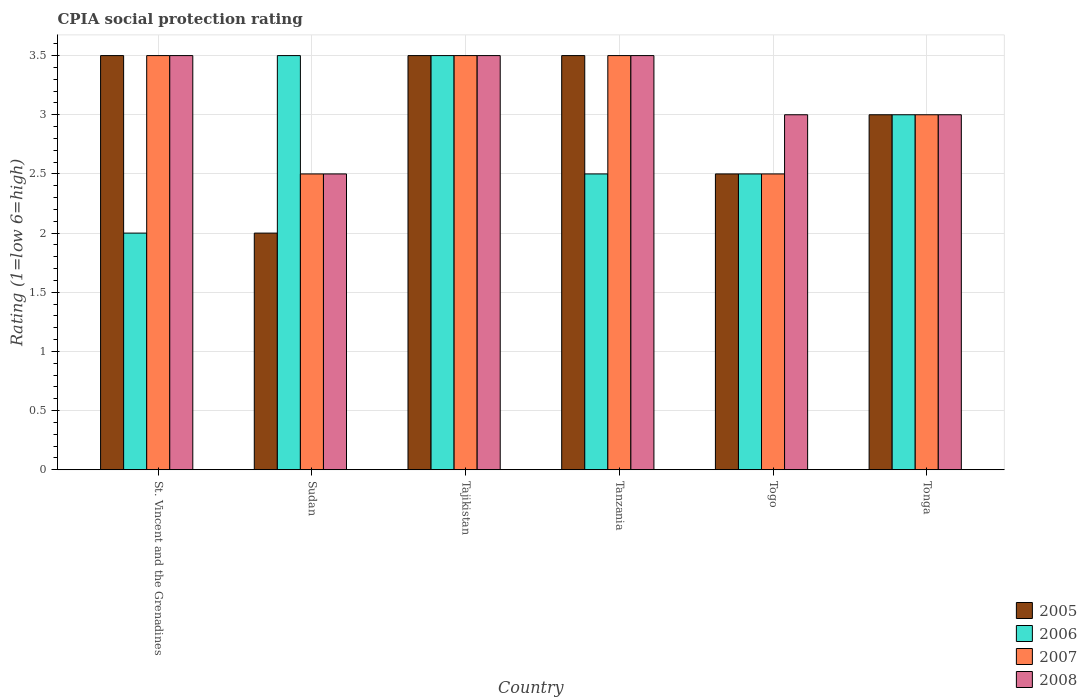How many different coloured bars are there?
Give a very brief answer. 4. Are the number of bars per tick equal to the number of legend labels?
Ensure brevity in your answer.  Yes. Are the number of bars on each tick of the X-axis equal?
Ensure brevity in your answer.  Yes. What is the label of the 2nd group of bars from the left?
Provide a short and direct response. Sudan. What is the CPIA rating in 2007 in Togo?
Give a very brief answer. 2.5. Across all countries, what is the minimum CPIA rating in 2008?
Your response must be concise. 2.5. In which country was the CPIA rating in 2008 maximum?
Your answer should be compact. St. Vincent and the Grenadines. In which country was the CPIA rating in 2006 minimum?
Your answer should be compact. St. Vincent and the Grenadines. What is the difference between the CPIA rating in 2005 in St. Vincent and the Grenadines and that in Tanzania?
Your response must be concise. 0. What is the difference between the CPIA rating in 2006 in Togo and the CPIA rating in 2008 in Tajikistan?
Your answer should be very brief. -1. Is the difference between the CPIA rating in 2006 in Sudan and Togo greater than the difference between the CPIA rating in 2008 in Sudan and Togo?
Provide a short and direct response. Yes. What is the difference between the highest and the second highest CPIA rating in 2006?
Ensure brevity in your answer.  -0.5. What is the difference between the highest and the lowest CPIA rating in 2005?
Keep it short and to the point. 1.5. What does the 2nd bar from the left in Tajikistan represents?
Your response must be concise. 2006. Is it the case that in every country, the sum of the CPIA rating in 2006 and CPIA rating in 2007 is greater than the CPIA rating in 2008?
Make the answer very short. Yes. How many bars are there?
Give a very brief answer. 24. Are all the bars in the graph horizontal?
Ensure brevity in your answer.  No. How many countries are there in the graph?
Ensure brevity in your answer.  6. Are the values on the major ticks of Y-axis written in scientific E-notation?
Give a very brief answer. No. Does the graph contain any zero values?
Offer a very short reply. No. Does the graph contain grids?
Your response must be concise. Yes. How are the legend labels stacked?
Your answer should be very brief. Vertical. What is the title of the graph?
Your answer should be very brief. CPIA social protection rating. What is the Rating (1=low 6=high) of 2005 in Sudan?
Provide a short and direct response. 2. What is the Rating (1=low 6=high) of 2006 in Sudan?
Ensure brevity in your answer.  3.5. What is the Rating (1=low 6=high) of 2007 in Sudan?
Provide a succinct answer. 2.5. What is the Rating (1=low 6=high) of 2008 in Sudan?
Offer a terse response. 2.5. What is the Rating (1=low 6=high) in 2005 in Tajikistan?
Provide a short and direct response. 3.5. What is the Rating (1=low 6=high) in 2008 in Tajikistan?
Give a very brief answer. 3.5. What is the Rating (1=low 6=high) in 2006 in Tanzania?
Keep it short and to the point. 2.5. What is the Rating (1=low 6=high) of 2008 in Tanzania?
Offer a very short reply. 3.5. What is the Rating (1=low 6=high) in 2005 in Togo?
Ensure brevity in your answer.  2.5. What is the Rating (1=low 6=high) of 2006 in Togo?
Provide a succinct answer. 2.5. What is the Rating (1=low 6=high) in 2008 in Togo?
Provide a succinct answer. 3. What is the Rating (1=low 6=high) in 2006 in Tonga?
Your answer should be very brief. 3. What is the Rating (1=low 6=high) of 2008 in Tonga?
Keep it short and to the point. 3. Across all countries, what is the maximum Rating (1=low 6=high) in 2005?
Give a very brief answer. 3.5. Across all countries, what is the maximum Rating (1=low 6=high) in 2007?
Ensure brevity in your answer.  3.5. Across all countries, what is the maximum Rating (1=low 6=high) in 2008?
Your answer should be compact. 3.5. Across all countries, what is the minimum Rating (1=low 6=high) in 2005?
Make the answer very short. 2. Across all countries, what is the minimum Rating (1=low 6=high) in 2006?
Make the answer very short. 2. What is the difference between the Rating (1=low 6=high) of 2006 in St. Vincent and the Grenadines and that in Tajikistan?
Ensure brevity in your answer.  -1.5. What is the difference between the Rating (1=low 6=high) of 2007 in St. Vincent and the Grenadines and that in Tajikistan?
Offer a terse response. 0. What is the difference between the Rating (1=low 6=high) in 2008 in St. Vincent and the Grenadines and that in Tajikistan?
Your answer should be compact. 0. What is the difference between the Rating (1=low 6=high) in 2006 in St. Vincent and the Grenadines and that in Tanzania?
Offer a very short reply. -0.5. What is the difference between the Rating (1=low 6=high) in 2008 in St. Vincent and the Grenadines and that in Tanzania?
Your answer should be very brief. 0. What is the difference between the Rating (1=low 6=high) of 2005 in St. Vincent and the Grenadines and that in Togo?
Offer a very short reply. 1. What is the difference between the Rating (1=low 6=high) in 2006 in St. Vincent and the Grenadines and that in Togo?
Provide a succinct answer. -0.5. What is the difference between the Rating (1=low 6=high) in 2005 in St. Vincent and the Grenadines and that in Tonga?
Keep it short and to the point. 0.5. What is the difference between the Rating (1=low 6=high) of 2007 in St. Vincent and the Grenadines and that in Tonga?
Provide a short and direct response. 0.5. What is the difference between the Rating (1=low 6=high) of 2008 in St. Vincent and the Grenadines and that in Tonga?
Provide a short and direct response. 0.5. What is the difference between the Rating (1=low 6=high) in 2005 in Sudan and that in Tajikistan?
Keep it short and to the point. -1.5. What is the difference between the Rating (1=low 6=high) in 2006 in Sudan and that in Tajikistan?
Make the answer very short. 0. What is the difference between the Rating (1=low 6=high) in 2008 in Sudan and that in Tajikistan?
Your response must be concise. -1. What is the difference between the Rating (1=low 6=high) in 2005 in Sudan and that in Tanzania?
Give a very brief answer. -1.5. What is the difference between the Rating (1=low 6=high) in 2006 in Sudan and that in Tanzania?
Provide a succinct answer. 1. What is the difference between the Rating (1=low 6=high) in 2007 in Sudan and that in Tanzania?
Make the answer very short. -1. What is the difference between the Rating (1=low 6=high) in 2008 in Sudan and that in Tanzania?
Offer a terse response. -1. What is the difference between the Rating (1=low 6=high) in 2007 in Sudan and that in Togo?
Ensure brevity in your answer.  0. What is the difference between the Rating (1=low 6=high) of 2008 in Sudan and that in Togo?
Provide a short and direct response. -0.5. What is the difference between the Rating (1=low 6=high) of 2007 in Sudan and that in Tonga?
Your answer should be very brief. -0.5. What is the difference between the Rating (1=low 6=high) in 2005 in Tajikistan and that in Togo?
Your answer should be very brief. 1. What is the difference between the Rating (1=low 6=high) of 2007 in Tajikistan and that in Togo?
Your answer should be very brief. 1. What is the difference between the Rating (1=low 6=high) of 2008 in Tajikistan and that in Togo?
Provide a short and direct response. 0.5. What is the difference between the Rating (1=low 6=high) of 2006 in Tajikistan and that in Tonga?
Offer a very short reply. 0.5. What is the difference between the Rating (1=low 6=high) of 2008 in Tajikistan and that in Tonga?
Offer a terse response. 0.5. What is the difference between the Rating (1=low 6=high) of 2007 in Tanzania and that in Togo?
Keep it short and to the point. 1. What is the difference between the Rating (1=low 6=high) of 2005 in Tanzania and that in Tonga?
Ensure brevity in your answer.  0.5. What is the difference between the Rating (1=low 6=high) in 2006 in Tanzania and that in Tonga?
Ensure brevity in your answer.  -0.5. What is the difference between the Rating (1=low 6=high) in 2008 in Tanzania and that in Tonga?
Offer a terse response. 0.5. What is the difference between the Rating (1=low 6=high) in 2005 in Togo and that in Tonga?
Your answer should be very brief. -0.5. What is the difference between the Rating (1=low 6=high) of 2008 in Togo and that in Tonga?
Your answer should be very brief. 0. What is the difference between the Rating (1=low 6=high) of 2005 in St. Vincent and the Grenadines and the Rating (1=low 6=high) of 2006 in Sudan?
Make the answer very short. 0. What is the difference between the Rating (1=low 6=high) of 2006 in St. Vincent and the Grenadines and the Rating (1=low 6=high) of 2007 in Sudan?
Your answer should be very brief. -0.5. What is the difference between the Rating (1=low 6=high) of 2006 in St. Vincent and the Grenadines and the Rating (1=low 6=high) of 2008 in Sudan?
Offer a very short reply. -0.5. What is the difference between the Rating (1=low 6=high) in 2005 in St. Vincent and the Grenadines and the Rating (1=low 6=high) in 2007 in Tajikistan?
Give a very brief answer. 0. What is the difference between the Rating (1=low 6=high) in 2005 in St. Vincent and the Grenadines and the Rating (1=low 6=high) in 2008 in Tajikistan?
Offer a very short reply. 0. What is the difference between the Rating (1=low 6=high) in 2006 in St. Vincent and the Grenadines and the Rating (1=low 6=high) in 2007 in Tajikistan?
Provide a short and direct response. -1.5. What is the difference between the Rating (1=low 6=high) of 2007 in St. Vincent and the Grenadines and the Rating (1=low 6=high) of 2008 in Tajikistan?
Your response must be concise. 0. What is the difference between the Rating (1=low 6=high) of 2005 in St. Vincent and the Grenadines and the Rating (1=low 6=high) of 2006 in Tanzania?
Provide a short and direct response. 1. What is the difference between the Rating (1=low 6=high) in 2005 in St. Vincent and the Grenadines and the Rating (1=low 6=high) in 2008 in Tanzania?
Offer a terse response. 0. What is the difference between the Rating (1=low 6=high) of 2006 in St. Vincent and the Grenadines and the Rating (1=low 6=high) of 2007 in Tanzania?
Your response must be concise. -1.5. What is the difference between the Rating (1=low 6=high) in 2005 in St. Vincent and the Grenadines and the Rating (1=low 6=high) in 2008 in Togo?
Provide a short and direct response. 0.5. What is the difference between the Rating (1=low 6=high) in 2005 in St. Vincent and the Grenadines and the Rating (1=low 6=high) in 2006 in Tonga?
Your answer should be compact. 0.5. What is the difference between the Rating (1=low 6=high) in 2006 in St. Vincent and the Grenadines and the Rating (1=low 6=high) in 2007 in Tonga?
Ensure brevity in your answer.  -1. What is the difference between the Rating (1=low 6=high) in 2006 in St. Vincent and the Grenadines and the Rating (1=low 6=high) in 2008 in Tonga?
Your answer should be very brief. -1. What is the difference between the Rating (1=low 6=high) in 2005 in Sudan and the Rating (1=low 6=high) in 2006 in Tajikistan?
Ensure brevity in your answer.  -1.5. What is the difference between the Rating (1=low 6=high) in 2005 in Sudan and the Rating (1=low 6=high) in 2008 in Tajikistan?
Offer a terse response. -1.5. What is the difference between the Rating (1=low 6=high) of 2006 in Sudan and the Rating (1=low 6=high) of 2007 in Tajikistan?
Your answer should be very brief. 0. What is the difference between the Rating (1=low 6=high) in 2006 in Sudan and the Rating (1=low 6=high) in 2008 in Tajikistan?
Offer a very short reply. 0. What is the difference between the Rating (1=low 6=high) in 2007 in Sudan and the Rating (1=low 6=high) in 2008 in Tajikistan?
Provide a succinct answer. -1. What is the difference between the Rating (1=low 6=high) in 2005 in Sudan and the Rating (1=low 6=high) in 2006 in Tanzania?
Make the answer very short. -0.5. What is the difference between the Rating (1=low 6=high) of 2005 in Sudan and the Rating (1=low 6=high) of 2007 in Tanzania?
Offer a very short reply. -1.5. What is the difference between the Rating (1=low 6=high) in 2005 in Sudan and the Rating (1=low 6=high) in 2008 in Tanzania?
Make the answer very short. -1.5. What is the difference between the Rating (1=low 6=high) in 2005 in Sudan and the Rating (1=low 6=high) in 2007 in Togo?
Your response must be concise. -0.5. What is the difference between the Rating (1=low 6=high) of 2005 in Sudan and the Rating (1=low 6=high) of 2006 in Tonga?
Make the answer very short. -1. What is the difference between the Rating (1=low 6=high) of 2006 in Sudan and the Rating (1=low 6=high) of 2008 in Tonga?
Your answer should be very brief. 0.5. What is the difference between the Rating (1=low 6=high) in 2005 in Tajikistan and the Rating (1=low 6=high) in 2006 in Tanzania?
Ensure brevity in your answer.  1. What is the difference between the Rating (1=low 6=high) in 2006 in Tajikistan and the Rating (1=low 6=high) in 2007 in Tanzania?
Your answer should be very brief. 0. What is the difference between the Rating (1=low 6=high) of 2006 in Tajikistan and the Rating (1=low 6=high) of 2008 in Tanzania?
Your answer should be very brief. 0. What is the difference between the Rating (1=low 6=high) in 2007 in Tajikistan and the Rating (1=low 6=high) in 2008 in Tanzania?
Keep it short and to the point. 0. What is the difference between the Rating (1=low 6=high) of 2006 in Tajikistan and the Rating (1=low 6=high) of 2007 in Togo?
Offer a terse response. 1. What is the difference between the Rating (1=low 6=high) of 2007 in Tajikistan and the Rating (1=low 6=high) of 2008 in Togo?
Your response must be concise. 0.5. What is the difference between the Rating (1=low 6=high) in 2005 in Tajikistan and the Rating (1=low 6=high) in 2006 in Tonga?
Give a very brief answer. 0.5. What is the difference between the Rating (1=low 6=high) of 2006 in Tajikistan and the Rating (1=low 6=high) of 2007 in Tonga?
Offer a terse response. 0.5. What is the difference between the Rating (1=low 6=high) in 2006 in Tajikistan and the Rating (1=low 6=high) in 2008 in Tonga?
Your answer should be very brief. 0.5. What is the difference between the Rating (1=low 6=high) in 2005 in Tanzania and the Rating (1=low 6=high) in 2007 in Togo?
Give a very brief answer. 1. What is the difference between the Rating (1=low 6=high) of 2005 in Tanzania and the Rating (1=low 6=high) of 2008 in Togo?
Your answer should be compact. 0.5. What is the difference between the Rating (1=low 6=high) in 2005 in Tanzania and the Rating (1=low 6=high) in 2007 in Tonga?
Give a very brief answer. 0.5. What is the difference between the Rating (1=low 6=high) in 2005 in Tanzania and the Rating (1=low 6=high) in 2008 in Tonga?
Keep it short and to the point. 0.5. What is the difference between the Rating (1=low 6=high) of 2007 in Tanzania and the Rating (1=low 6=high) of 2008 in Tonga?
Provide a succinct answer. 0.5. What is the difference between the Rating (1=low 6=high) of 2005 in Togo and the Rating (1=low 6=high) of 2006 in Tonga?
Ensure brevity in your answer.  -0.5. What is the difference between the Rating (1=low 6=high) of 2006 in Togo and the Rating (1=low 6=high) of 2007 in Tonga?
Your answer should be very brief. -0.5. What is the difference between the Rating (1=low 6=high) of 2007 in Togo and the Rating (1=low 6=high) of 2008 in Tonga?
Make the answer very short. -0.5. What is the average Rating (1=low 6=high) of 2005 per country?
Offer a very short reply. 3. What is the average Rating (1=low 6=high) of 2006 per country?
Offer a very short reply. 2.83. What is the average Rating (1=low 6=high) of 2007 per country?
Your response must be concise. 3.08. What is the average Rating (1=low 6=high) in 2008 per country?
Your answer should be compact. 3.17. What is the difference between the Rating (1=low 6=high) of 2005 and Rating (1=low 6=high) of 2007 in St. Vincent and the Grenadines?
Your answer should be compact. 0. What is the difference between the Rating (1=low 6=high) in 2005 and Rating (1=low 6=high) in 2008 in St. Vincent and the Grenadines?
Give a very brief answer. 0. What is the difference between the Rating (1=low 6=high) in 2006 and Rating (1=low 6=high) in 2008 in St. Vincent and the Grenadines?
Give a very brief answer. -1.5. What is the difference between the Rating (1=low 6=high) in 2005 and Rating (1=low 6=high) in 2006 in Sudan?
Your answer should be very brief. -1.5. What is the difference between the Rating (1=low 6=high) of 2005 and Rating (1=low 6=high) of 2007 in Sudan?
Provide a succinct answer. -0.5. What is the difference between the Rating (1=low 6=high) of 2007 and Rating (1=low 6=high) of 2008 in Sudan?
Your answer should be compact. 0. What is the difference between the Rating (1=low 6=high) in 2005 and Rating (1=low 6=high) in 2006 in Tajikistan?
Offer a terse response. 0. What is the difference between the Rating (1=low 6=high) of 2005 and Rating (1=low 6=high) of 2008 in Tajikistan?
Offer a terse response. 0. What is the difference between the Rating (1=low 6=high) in 2005 and Rating (1=low 6=high) in 2008 in Tanzania?
Give a very brief answer. 0. What is the difference between the Rating (1=low 6=high) in 2006 and Rating (1=low 6=high) in 2008 in Tanzania?
Offer a very short reply. -1. What is the difference between the Rating (1=low 6=high) of 2007 and Rating (1=low 6=high) of 2008 in Tanzania?
Give a very brief answer. 0. What is the difference between the Rating (1=low 6=high) in 2005 and Rating (1=low 6=high) in 2006 in Togo?
Offer a very short reply. 0. What is the difference between the Rating (1=low 6=high) of 2005 and Rating (1=low 6=high) of 2008 in Togo?
Your answer should be compact. -0.5. What is the difference between the Rating (1=low 6=high) of 2007 and Rating (1=low 6=high) of 2008 in Togo?
Your answer should be compact. -0.5. What is the difference between the Rating (1=low 6=high) of 2005 and Rating (1=low 6=high) of 2006 in Tonga?
Make the answer very short. 0. What is the difference between the Rating (1=low 6=high) of 2006 and Rating (1=low 6=high) of 2008 in Tonga?
Your answer should be compact. 0. What is the difference between the Rating (1=low 6=high) in 2007 and Rating (1=low 6=high) in 2008 in Tonga?
Offer a very short reply. 0. What is the ratio of the Rating (1=low 6=high) of 2006 in St. Vincent and the Grenadines to that in Sudan?
Your answer should be compact. 0.57. What is the ratio of the Rating (1=low 6=high) in 2008 in St. Vincent and the Grenadines to that in Sudan?
Your answer should be compact. 1.4. What is the ratio of the Rating (1=low 6=high) in 2006 in St. Vincent and the Grenadines to that in Tajikistan?
Keep it short and to the point. 0.57. What is the ratio of the Rating (1=low 6=high) of 2007 in St. Vincent and the Grenadines to that in Tajikistan?
Ensure brevity in your answer.  1. What is the ratio of the Rating (1=low 6=high) of 2008 in St. Vincent and the Grenadines to that in Tajikistan?
Give a very brief answer. 1. What is the ratio of the Rating (1=low 6=high) in 2007 in St. Vincent and the Grenadines to that in Tanzania?
Provide a short and direct response. 1. What is the ratio of the Rating (1=low 6=high) of 2007 in St. Vincent and the Grenadines to that in Togo?
Keep it short and to the point. 1.4. What is the ratio of the Rating (1=low 6=high) in 2008 in St. Vincent and the Grenadines to that in Tonga?
Keep it short and to the point. 1.17. What is the ratio of the Rating (1=low 6=high) in 2005 in Sudan to that in Tajikistan?
Your response must be concise. 0.57. What is the ratio of the Rating (1=low 6=high) of 2007 in Sudan to that in Tajikistan?
Your response must be concise. 0.71. What is the ratio of the Rating (1=low 6=high) of 2005 in Sudan to that in Tanzania?
Your answer should be compact. 0.57. What is the ratio of the Rating (1=low 6=high) of 2007 in Sudan to that in Tanzania?
Keep it short and to the point. 0.71. What is the ratio of the Rating (1=low 6=high) of 2008 in Sudan to that in Tanzania?
Give a very brief answer. 0.71. What is the ratio of the Rating (1=low 6=high) in 2005 in Sudan to that in Togo?
Your answer should be very brief. 0.8. What is the ratio of the Rating (1=low 6=high) of 2006 in Sudan to that in Togo?
Keep it short and to the point. 1.4. What is the ratio of the Rating (1=low 6=high) in 2005 in Sudan to that in Tonga?
Provide a succinct answer. 0.67. What is the ratio of the Rating (1=low 6=high) in 2007 in Sudan to that in Tonga?
Offer a very short reply. 0.83. What is the ratio of the Rating (1=low 6=high) in 2005 in Tajikistan to that in Tanzania?
Give a very brief answer. 1. What is the ratio of the Rating (1=low 6=high) in 2008 in Tajikistan to that in Tanzania?
Provide a short and direct response. 1. What is the ratio of the Rating (1=low 6=high) of 2005 in Tajikistan to that in Togo?
Keep it short and to the point. 1.4. What is the ratio of the Rating (1=low 6=high) in 2007 in Tajikistan to that in Togo?
Provide a short and direct response. 1.4. What is the ratio of the Rating (1=low 6=high) in 2005 in Tajikistan to that in Tonga?
Give a very brief answer. 1.17. What is the ratio of the Rating (1=low 6=high) in 2006 in Tajikistan to that in Tonga?
Ensure brevity in your answer.  1.17. What is the ratio of the Rating (1=low 6=high) in 2008 in Tajikistan to that in Tonga?
Ensure brevity in your answer.  1.17. What is the ratio of the Rating (1=low 6=high) in 2005 in Tanzania to that in Togo?
Give a very brief answer. 1.4. What is the ratio of the Rating (1=low 6=high) in 2006 in Tanzania to that in Togo?
Your answer should be compact. 1. What is the ratio of the Rating (1=low 6=high) in 2007 in Tanzania to that in Togo?
Offer a terse response. 1.4. What is the ratio of the Rating (1=low 6=high) in 2008 in Tanzania to that in Togo?
Offer a terse response. 1.17. What is the ratio of the Rating (1=low 6=high) of 2005 in Tanzania to that in Tonga?
Make the answer very short. 1.17. What is the ratio of the Rating (1=low 6=high) of 2006 in Tanzania to that in Tonga?
Make the answer very short. 0.83. What is the ratio of the Rating (1=low 6=high) of 2005 in Togo to that in Tonga?
Provide a short and direct response. 0.83. What is the ratio of the Rating (1=low 6=high) in 2006 in Togo to that in Tonga?
Your response must be concise. 0.83. What is the ratio of the Rating (1=low 6=high) in 2007 in Togo to that in Tonga?
Offer a very short reply. 0.83. What is the difference between the highest and the second highest Rating (1=low 6=high) of 2007?
Give a very brief answer. 0. What is the difference between the highest and the second highest Rating (1=low 6=high) of 2008?
Give a very brief answer. 0. What is the difference between the highest and the lowest Rating (1=low 6=high) in 2005?
Your response must be concise. 1.5. What is the difference between the highest and the lowest Rating (1=low 6=high) of 2008?
Ensure brevity in your answer.  1. 